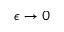Convert formula to latex. <formula><loc_0><loc_0><loc_500><loc_500>\epsilon \rightarrow 0</formula> 